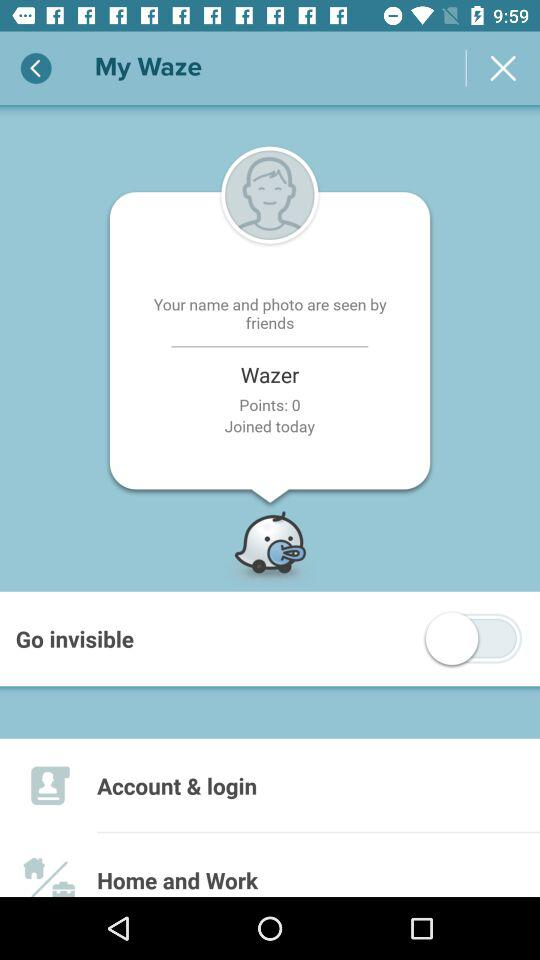What is the status of the "Go invisible"? The status is "off". 